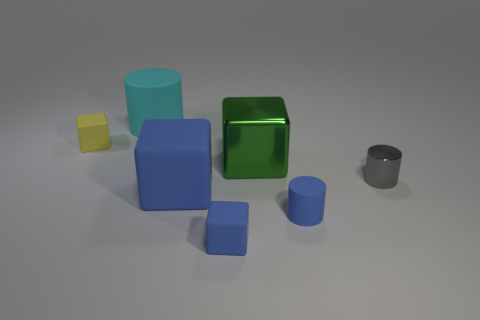Subtract all green metallic blocks. How many blocks are left? 3 Add 1 yellow objects. How many objects exist? 8 Subtract all blue balls. How many blue blocks are left? 2 Subtract all green blocks. How many blocks are left? 3 Subtract all cubes. How many objects are left? 3 Subtract all green cylinders. Subtract all green balls. How many cylinders are left? 3 Subtract all big green balls. Subtract all large metallic things. How many objects are left? 6 Add 1 tiny shiny things. How many tiny shiny things are left? 2 Add 3 small matte objects. How many small matte objects exist? 6 Subtract 0 green balls. How many objects are left? 7 